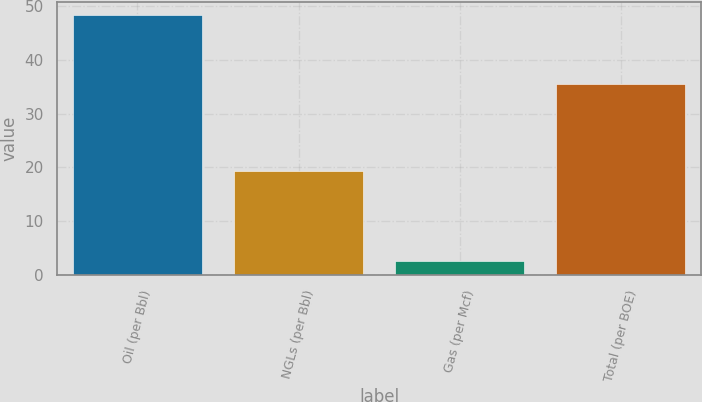Convert chart. <chart><loc_0><loc_0><loc_500><loc_500><bar_chart><fcel>Oil (per Bbl)<fcel>NGLs (per Bbl)<fcel>Gas (per Mcf)<fcel>Total (per BOE)<nl><fcel>48.24<fcel>19.31<fcel>2.63<fcel>35.39<nl></chart> 